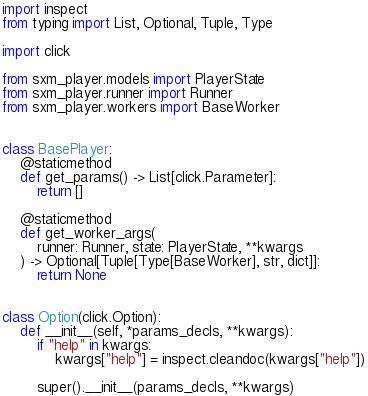<code> <loc_0><loc_0><loc_500><loc_500><_Python_>import inspect
from typing import List, Optional, Tuple, Type

import click

from sxm_player.models import PlayerState
from sxm_player.runner import Runner
from sxm_player.workers import BaseWorker


class BasePlayer:
    @staticmethod
    def get_params() -> List[click.Parameter]:
        return []

    @staticmethod
    def get_worker_args(
        runner: Runner, state: PlayerState, **kwargs
    ) -> Optional[Tuple[Type[BaseWorker], str, dict]]:
        return None


class Option(click.Option):
    def __init__(self, *params_decls, **kwargs):
        if "help" in kwargs:
            kwargs["help"] = inspect.cleandoc(kwargs["help"])

        super().__init__(params_decls, **kwargs)
</code> 